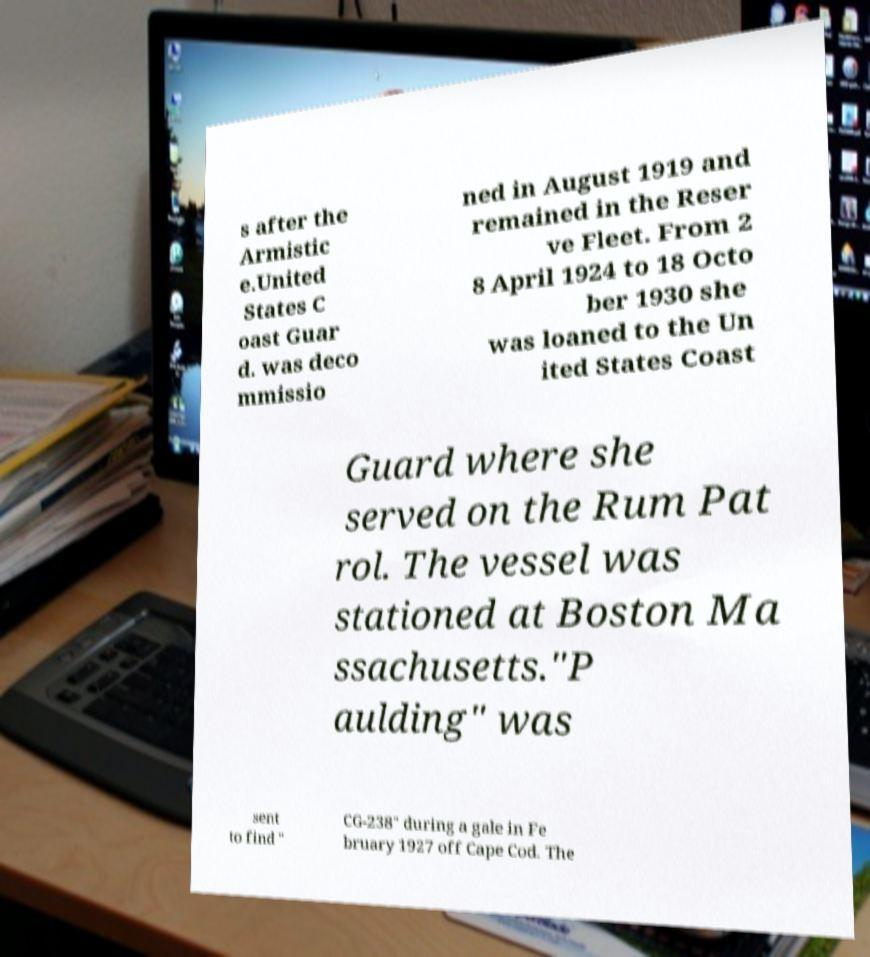Can you read and provide the text displayed in the image?This photo seems to have some interesting text. Can you extract and type it out for me? s after the Armistic e.United States C oast Guar d. was deco mmissio ned in August 1919 and remained in the Reser ve Fleet. From 2 8 April 1924 to 18 Octo ber 1930 she was loaned to the Un ited States Coast Guard where she served on the Rum Pat rol. The vessel was stationed at Boston Ma ssachusetts."P aulding" was sent to find " CG-238" during a gale in Fe bruary 1927 off Cape Cod. The 